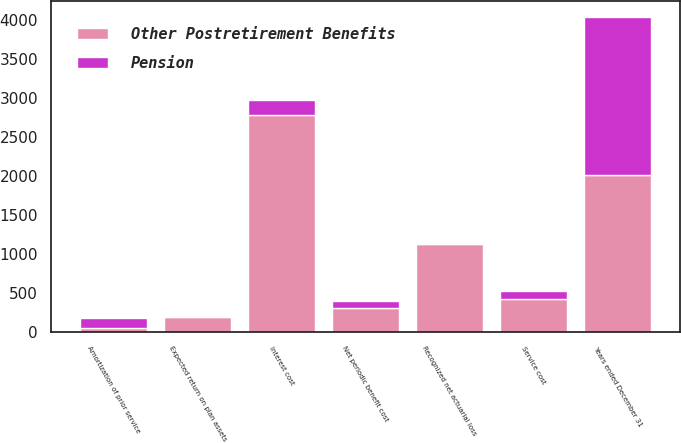Convert chart to OTSL. <chart><loc_0><loc_0><loc_500><loc_500><stacked_bar_chart><ecel><fcel>Years ended December 31<fcel>Service cost<fcel>Interest cost<fcel>Expected return on plan assets<fcel>Amortization of prior service<fcel>Recognized net actuarial loss<fcel>Net periodic benefit cost<nl><fcel>Other Postretirement Benefits<fcel>2018<fcel>430<fcel>2781<fcel>194<fcel>56<fcel>1130<fcel>313<nl><fcel>Pension<fcel>2018<fcel>94<fcel>194<fcel>8<fcel>126<fcel>10<fcel>84<nl></chart> 